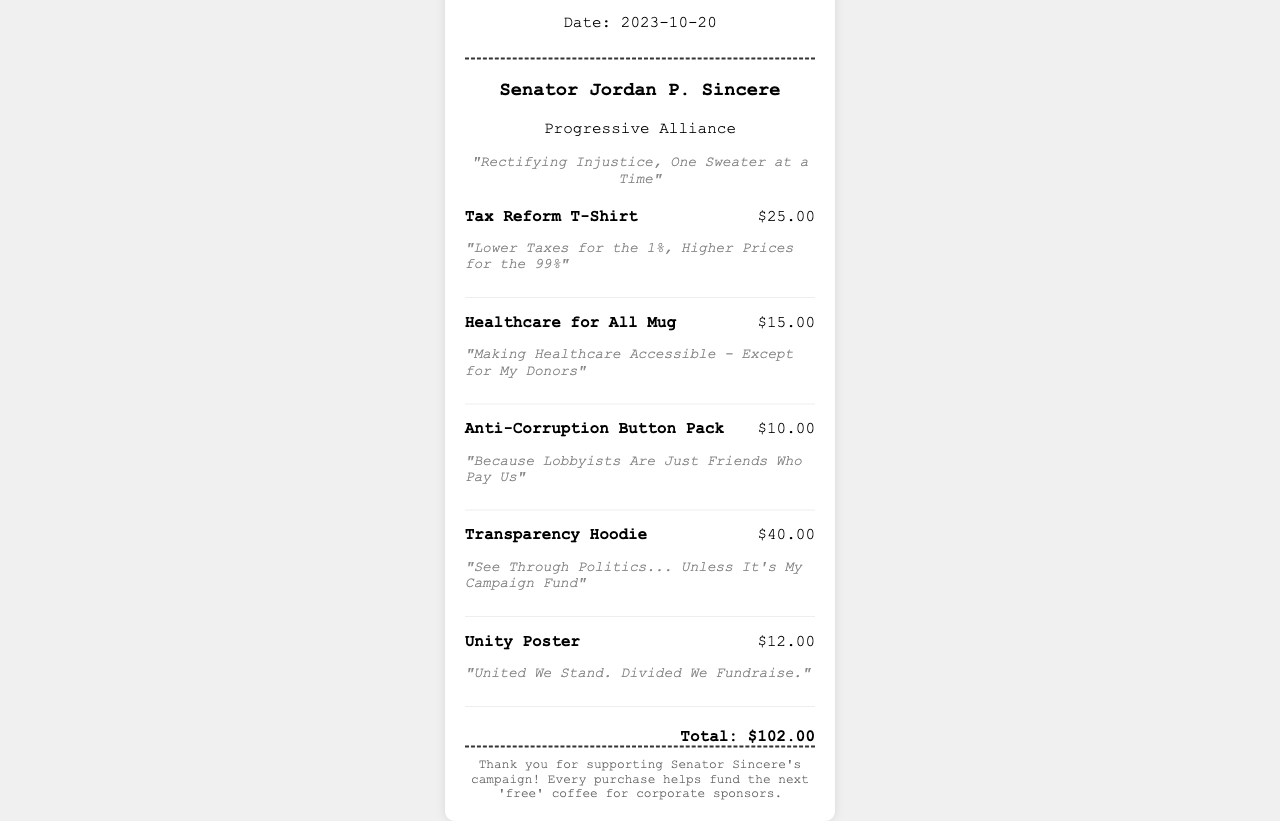What is the date of the receipt? The receipt lists the date at the top under the header.
Answer: 2023-10-20 Who is the politician featured on the receipt? The politician's name is shown in the politician information section.
Answer: Senator Jordan P. Sincere What is the tagline associated with Senator Sincere? The tagline is provided right below the politician's name.
Answer: "Rectifying Injustice, One Sweater at a Time" How much does the Transparency Hoodie cost? The cost is specified next to the item name in the items section.
Answer: $40.00 What is the total amount spent on items? The total is calculated at the bottom of the receipt.
Answer: $102.00 What is the tagline for the Tax Reform T-Shirt? The tagline is located beneath the item name in the items section.
Answer: "Lower Taxes for the 1%, Higher Prices for the 99%" How many items are listed in the receipt? The total number of items can be counted from the items section.
Answer: 5 What specific political stance does Senator Sincere claim to support? This can be inferred from the party affiliation stated in the document.
Answer: Progressive Alliance What does the footer suggest about the purchases? The footer contains a humorous statement regarding the purpose of the funds from purchases.
Answer: Corporate sponsors 